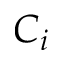<formula> <loc_0><loc_0><loc_500><loc_500>C _ { i }</formula> 